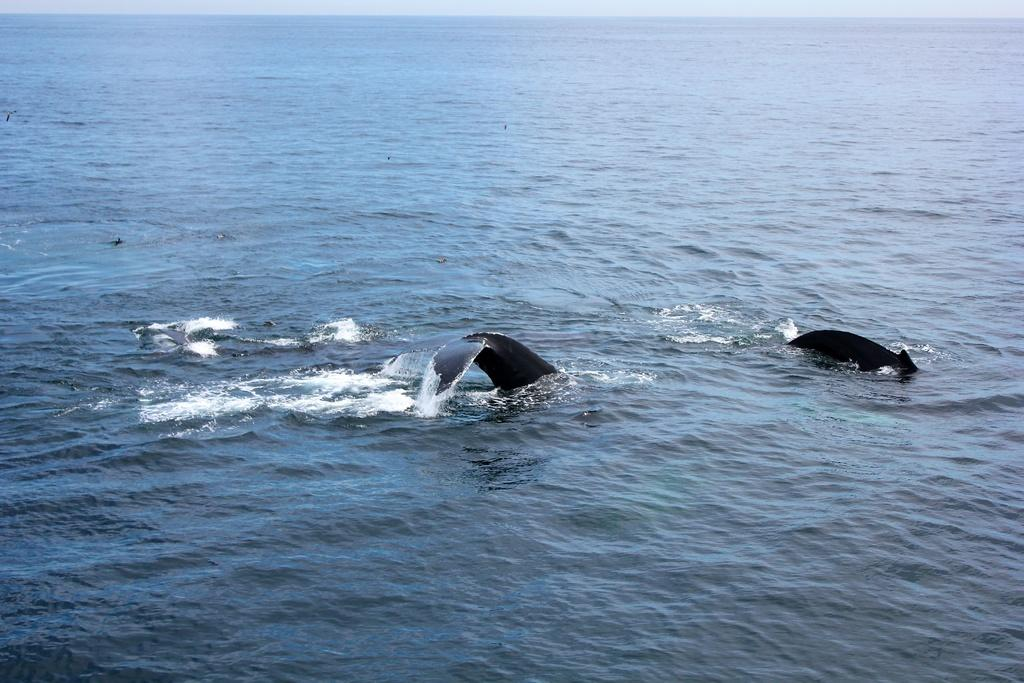What type of animals can be seen in the image? There are sea animals in the image. Where are the sea animals located? The sea animals are in the water. What type of branch can be seen in the image? There is no branch present in the image; it features sea animals in the water. What color is the dress worn by the sea animals in the image? There is no dress present in the image; sea animals do not wear clothing. 